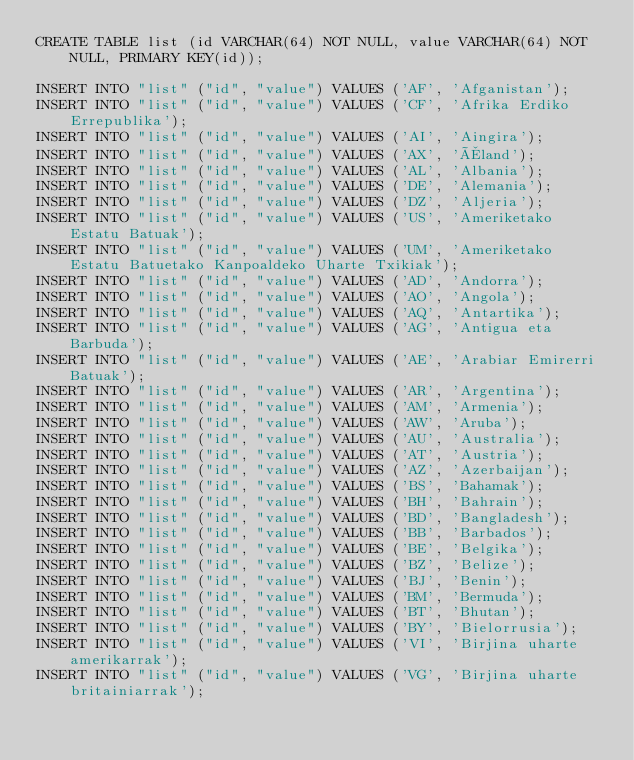<code> <loc_0><loc_0><loc_500><loc_500><_SQL_>CREATE TABLE list (id VARCHAR(64) NOT NULL, value VARCHAR(64) NOT NULL, PRIMARY KEY(id));

INSERT INTO "list" ("id", "value") VALUES ('AF', 'Afganistan');
INSERT INTO "list" ("id", "value") VALUES ('CF', 'Afrika Erdiko Errepublika');
INSERT INTO "list" ("id", "value") VALUES ('AI', 'Aingira');
INSERT INTO "list" ("id", "value") VALUES ('AX', 'Åland');
INSERT INTO "list" ("id", "value") VALUES ('AL', 'Albania');
INSERT INTO "list" ("id", "value") VALUES ('DE', 'Alemania');
INSERT INTO "list" ("id", "value") VALUES ('DZ', 'Aljeria');
INSERT INTO "list" ("id", "value") VALUES ('US', 'Ameriketako Estatu Batuak');
INSERT INTO "list" ("id", "value") VALUES ('UM', 'Ameriketako Estatu Batuetako Kanpoaldeko Uharte Txikiak');
INSERT INTO "list" ("id", "value") VALUES ('AD', 'Andorra');
INSERT INTO "list" ("id", "value") VALUES ('AO', 'Angola');
INSERT INTO "list" ("id", "value") VALUES ('AQ', 'Antartika');
INSERT INTO "list" ("id", "value") VALUES ('AG', 'Antigua eta Barbuda');
INSERT INTO "list" ("id", "value") VALUES ('AE', 'Arabiar Emirerri Batuak');
INSERT INTO "list" ("id", "value") VALUES ('AR', 'Argentina');
INSERT INTO "list" ("id", "value") VALUES ('AM', 'Armenia');
INSERT INTO "list" ("id", "value") VALUES ('AW', 'Aruba');
INSERT INTO "list" ("id", "value") VALUES ('AU', 'Australia');
INSERT INTO "list" ("id", "value") VALUES ('AT', 'Austria');
INSERT INTO "list" ("id", "value") VALUES ('AZ', 'Azerbaijan');
INSERT INTO "list" ("id", "value") VALUES ('BS', 'Bahamak');
INSERT INTO "list" ("id", "value") VALUES ('BH', 'Bahrain');
INSERT INTO "list" ("id", "value") VALUES ('BD', 'Bangladesh');
INSERT INTO "list" ("id", "value") VALUES ('BB', 'Barbados');
INSERT INTO "list" ("id", "value") VALUES ('BE', 'Belgika');
INSERT INTO "list" ("id", "value") VALUES ('BZ', 'Belize');
INSERT INTO "list" ("id", "value") VALUES ('BJ', 'Benin');
INSERT INTO "list" ("id", "value") VALUES ('BM', 'Bermuda');
INSERT INTO "list" ("id", "value") VALUES ('BT', 'Bhutan');
INSERT INTO "list" ("id", "value") VALUES ('BY', 'Bielorrusia');
INSERT INTO "list" ("id", "value") VALUES ('VI', 'Birjina uharte amerikarrak');
INSERT INTO "list" ("id", "value") VALUES ('VG', 'Birjina uharte britainiarrak');</code> 